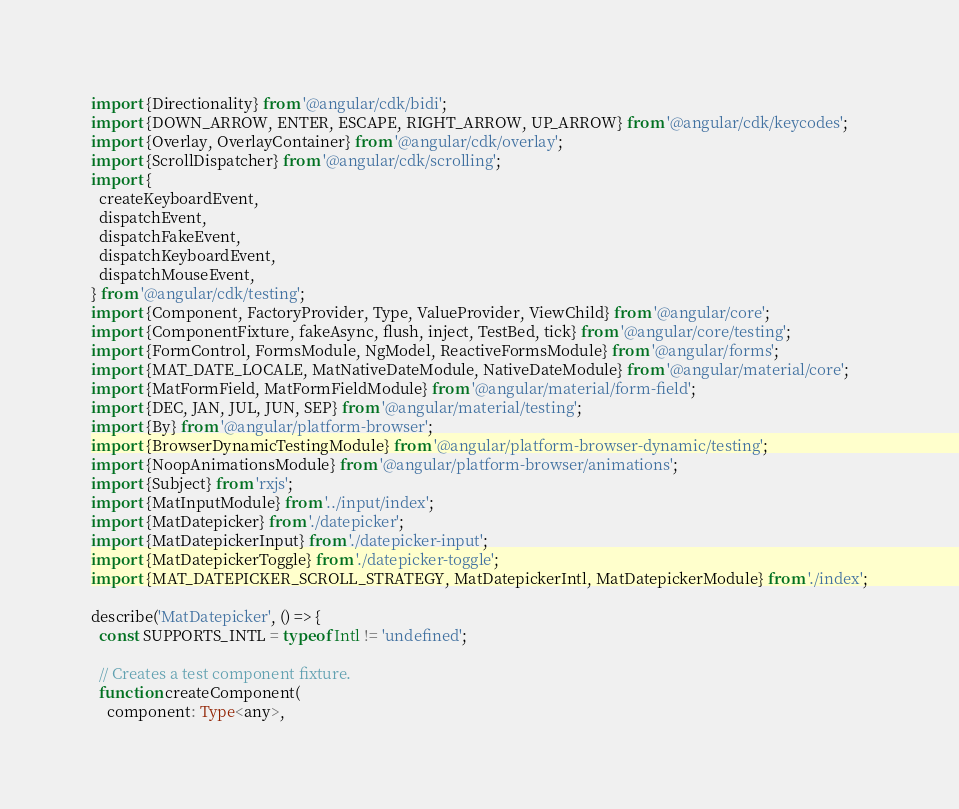Convert code to text. <code><loc_0><loc_0><loc_500><loc_500><_TypeScript_>import {Directionality} from '@angular/cdk/bidi';
import {DOWN_ARROW, ENTER, ESCAPE, RIGHT_ARROW, UP_ARROW} from '@angular/cdk/keycodes';
import {Overlay, OverlayContainer} from '@angular/cdk/overlay';
import {ScrollDispatcher} from '@angular/cdk/scrolling';
import {
  createKeyboardEvent,
  dispatchEvent,
  dispatchFakeEvent,
  dispatchKeyboardEvent,
  dispatchMouseEvent,
} from '@angular/cdk/testing';
import {Component, FactoryProvider, Type, ValueProvider, ViewChild} from '@angular/core';
import {ComponentFixture, fakeAsync, flush, inject, TestBed, tick} from '@angular/core/testing';
import {FormControl, FormsModule, NgModel, ReactiveFormsModule} from '@angular/forms';
import {MAT_DATE_LOCALE, MatNativeDateModule, NativeDateModule} from '@angular/material/core';
import {MatFormField, MatFormFieldModule} from '@angular/material/form-field';
import {DEC, JAN, JUL, JUN, SEP} from '@angular/material/testing';
import {By} from '@angular/platform-browser';
import {BrowserDynamicTestingModule} from '@angular/platform-browser-dynamic/testing';
import {NoopAnimationsModule} from '@angular/platform-browser/animations';
import {Subject} from 'rxjs';
import {MatInputModule} from '../input/index';
import {MatDatepicker} from './datepicker';
import {MatDatepickerInput} from './datepicker-input';
import {MatDatepickerToggle} from './datepicker-toggle';
import {MAT_DATEPICKER_SCROLL_STRATEGY, MatDatepickerIntl, MatDatepickerModule} from './index';

describe('MatDatepicker', () => {
  const SUPPORTS_INTL = typeof Intl != 'undefined';

  // Creates a test component fixture.
  function createComponent(
    component: Type<any>,</code> 